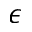<formula> <loc_0><loc_0><loc_500><loc_500>\epsilon</formula> 